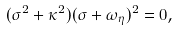Convert formula to latex. <formula><loc_0><loc_0><loc_500><loc_500>( \sigma ^ { 2 } + \kappa ^ { 2 } ) ( \sigma + \omega _ { \eta } ) ^ { 2 } = 0 ,</formula> 